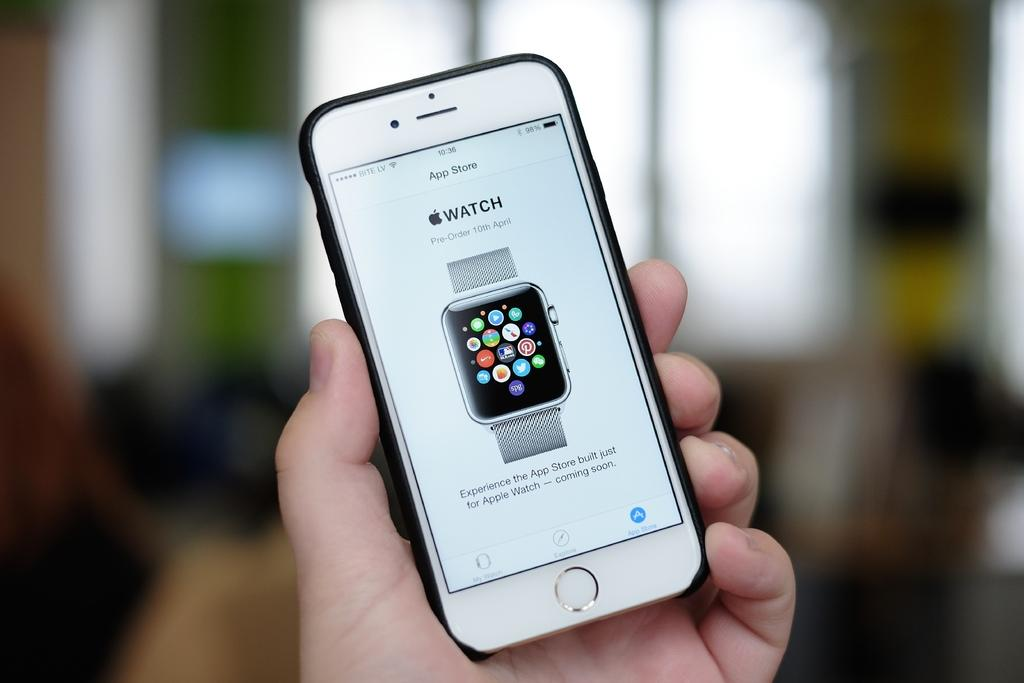<image>
Share a concise interpretation of the image provided. A phone with the word watch visible on the screen. 